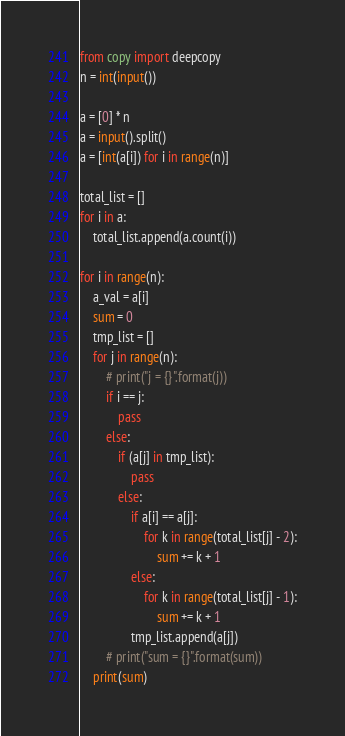<code> <loc_0><loc_0><loc_500><loc_500><_Python_>from copy import deepcopy
n = int(input())

a = [0] * n
a = input().split()
a = [int(a[i]) for i in range(n)]

total_list = []
for i in a:
    total_list.append(a.count(i))

for i in range(n):
    a_val = a[i]
    sum = 0
    tmp_list = []
    for j in range(n):
        # print("j = {}".format(j))
        if i == j:
            pass
        else:
            if (a[j] in tmp_list):
                pass
            else:
                if a[i] == a[j]:
                    for k in range(total_list[j] - 2):
                        sum += k + 1
                else:
                    for k in range(total_list[j] - 1):
                        sum += k + 1
                tmp_list.append(a[j])
        # print("sum = {}".format(sum))
    print(sum)
</code> 